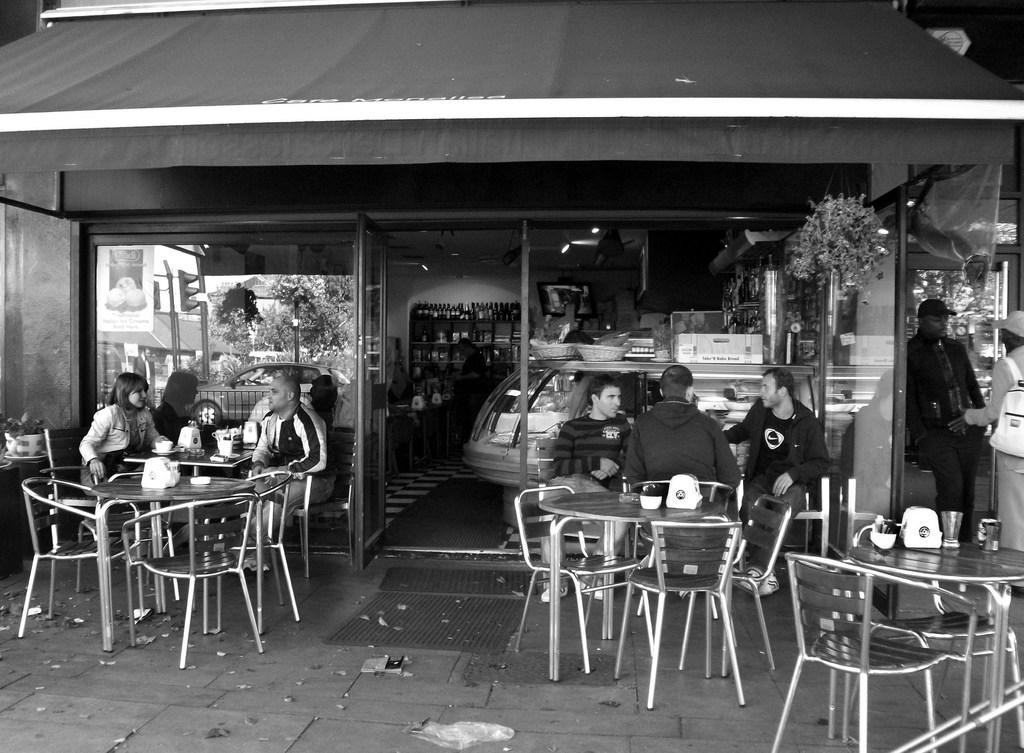What are the people in the image doing? The group of people is sitting on chairs. What is in front of the chairs? There is a table in front of the chairs. What can be found on the table? There are objects on the table. Where is the door located in the image? There is a door in the image. What else is present in the image besides the people and table? There are bottles in the image. What type of tray is being used by the giants in the image? There are no giants or trays present in the image. 